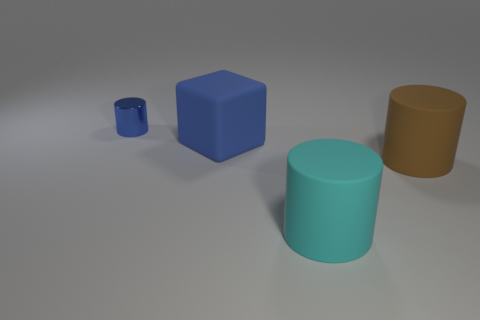There is a cube that is the same color as the metallic cylinder; what material is it?
Offer a very short reply. Rubber. What color is the matte object that is on the left side of the large brown matte cylinder and behind the cyan thing?
Provide a succinct answer. Blue. There is a cylinder that is behind the blue object in front of the small cylinder; what is its material?
Give a very brief answer. Metal. The other brown object that is the same shape as the metal object is what size?
Provide a short and direct response. Large. There is a matte cylinder to the right of the cyan cylinder; does it have the same color as the tiny thing?
Your response must be concise. No. Is the number of tiny blue cylinders less than the number of purple rubber cubes?
Your answer should be compact. No. What number of other objects are there of the same color as the tiny shiny object?
Keep it short and to the point. 1. Do the blue thing to the right of the tiny blue object and the small blue cylinder have the same material?
Provide a short and direct response. No. There is a blue thing that is to the right of the metallic object; what is it made of?
Offer a very short reply. Rubber. There is a blue cylinder behind the blue object to the right of the metallic cylinder; what is its size?
Provide a succinct answer. Small. 